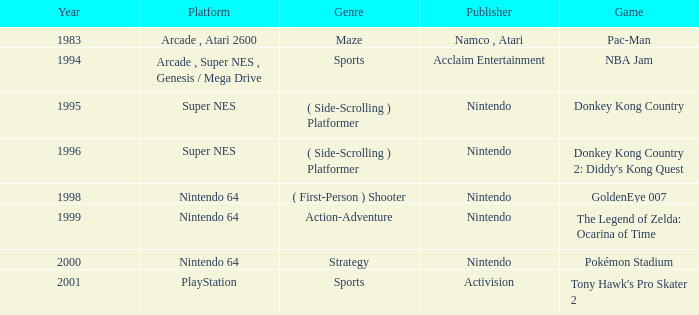Which Genre has a Game of donkey kong country? ( Side-Scrolling ) Platformer. 